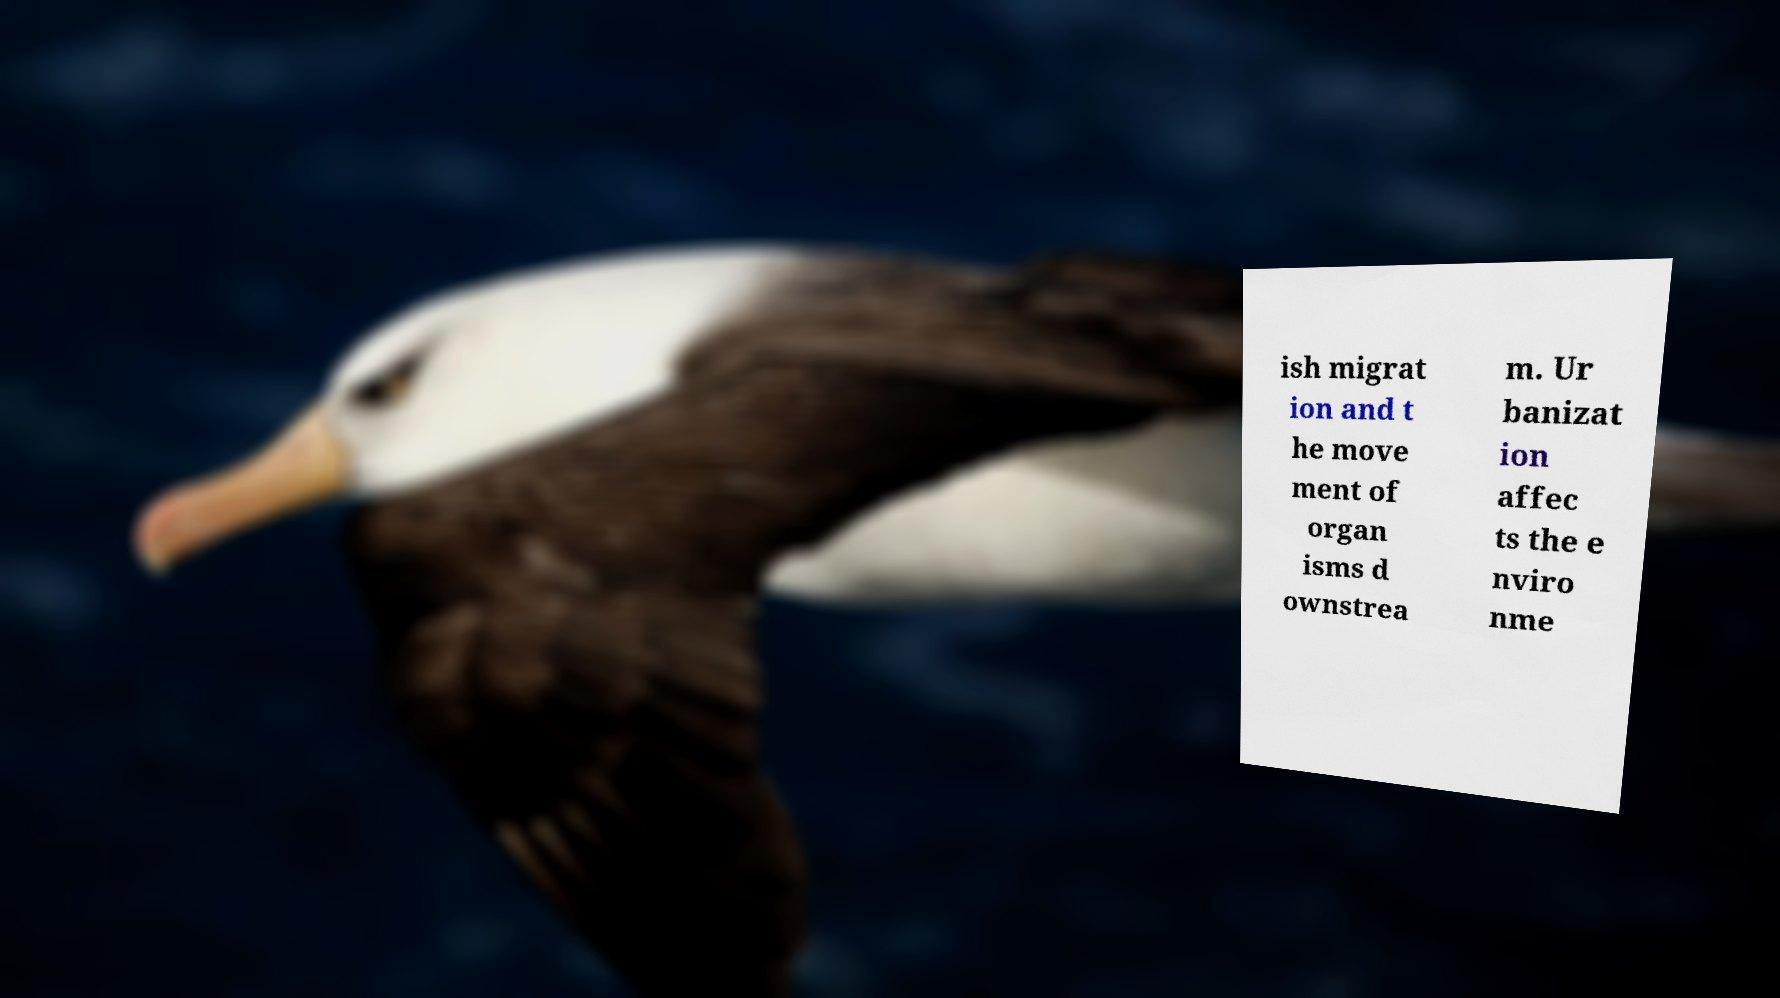Please identify and transcribe the text found in this image. ish migrat ion and t he move ment of organ isms d ownstrea m. Ur banizat ion affec ts the e nviro nme 